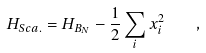<formula> <loc_0><loc_0><loc_500><loc_500>H _ { S c a . } = H _ { B _ { N } } - \frac { 1 } { 2 } \sum _ { i } x _ { i } ^ { 2 } \quad ,</formula> 